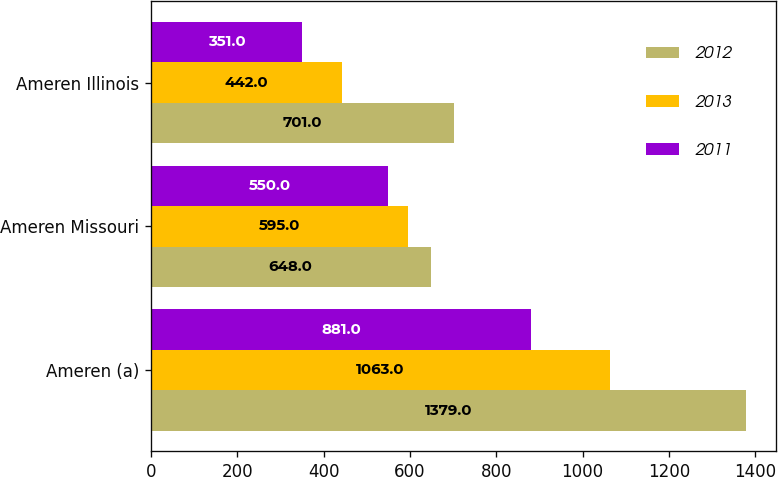Convert chart. <chart><loc_0><loc_0><loc_500><loc_500><stacked_bar_chart><ecel><fcel>Ameren (a)<fcel>Ameren Missouri<fcel>Ameren Illinois<nl><fcel>2012<fcel>1379<fcel>648<fcel>701<nl><fcel>2013<fcel>1063<fcel>595<fcel>442<nl><fcel>2011<fcel>881<fcel>550<fcel>351<nl></chart> 